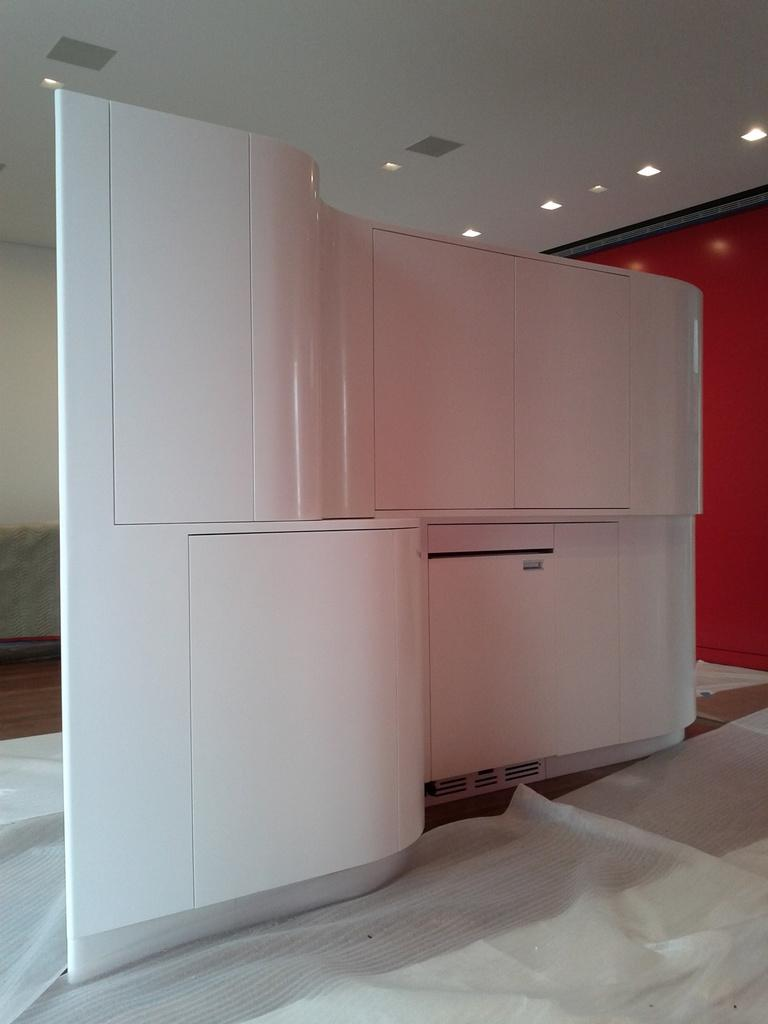What type of objects can be seen in the image? There is furniture in the image. What is covering the floor in the image? There are white sheets on the floor. What can be seen in the background of the image? There is a wall visible in the background of the image. What is providing illumination in the image? There are lights at the top of the image. Can you see a river flowing through the room in the image? No, there is no river visible in the image. 